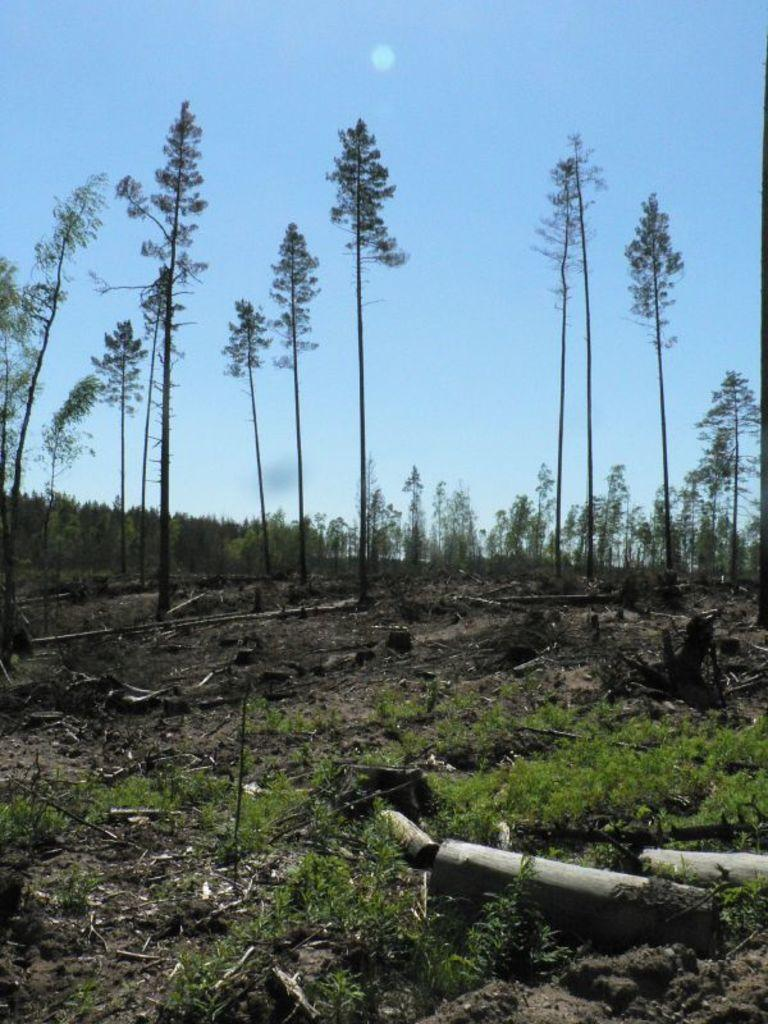What type of living organisms can be seen in the image? Plants and trees are visible in the image. What type of wooden material is present in the image? There are wooden logs in the image. What other plant-based material can be seen in the image? There are twigs in the image. What is visible in the background of the image? The sky is visible in the background of the image. What type of brick material can be seen in the image? There is no brick material present in the image. What type of linen fabric can be seen draped over the trees in the image? There is no linen fabric present in the image, and the trees are not draped with any fabric. 